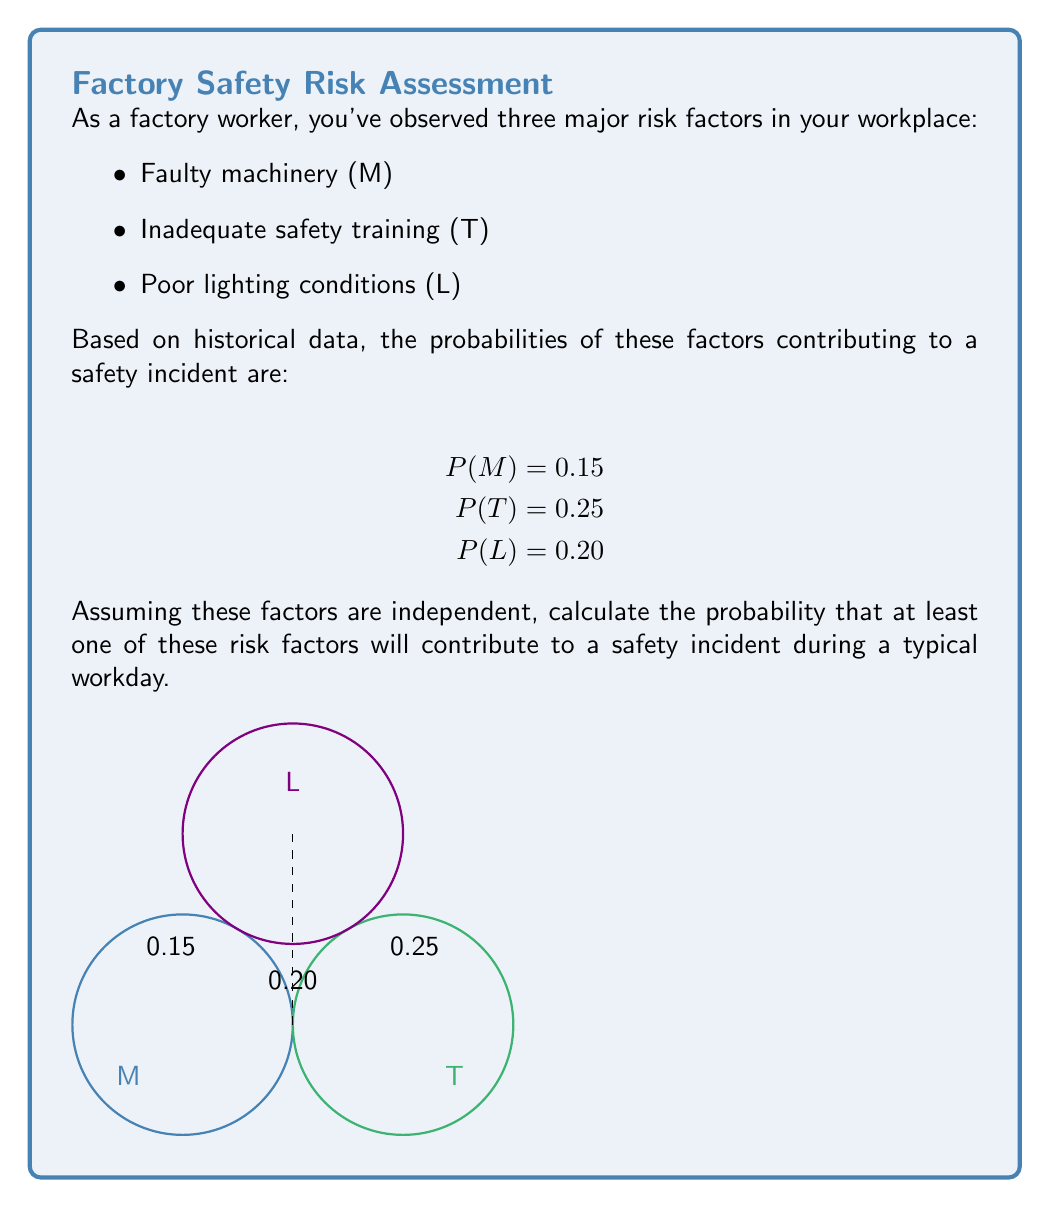Could you help me with this problem? Let's approach this step-by-step using the complement method:

1) First, we need to find the probability that none of the risk factors contribute to a safety incident. This is equivalent to the probability that all factors do not occur.

2) For each factor, the probability of it not occurring is:
   P(not M) = 1 - P(M) = 1 - 0.15 = 0.85
   P(not T) = 1 - P(T) = 1 - 0.25 = 0.75
   P(not L) = 1 - P(L) = 1 - 0.20 = 0.80

3) Since the factors are independent, we can multiply these probabilities:
   P(none occur) = P(not M) × P(not T) × P(not L)
                 = 0.85 × 0.75 × 0.80
                 = 0.51

4) Now, the probability that at least one factor contributes to a safety incident is the complement of the probability that none occur:

   P(at least one occurs) = 1 - P(none occur)
                          = 1 - 0.51
                          = 0.49

5) We can also express this using the equation:

   $$P(\text{at least one}) = 1 - (1-P(M))(1-P(T))(1-P(L))$$

Therefore, the probability that at least one of these risk factors will contribute to a safety incident during a typical workday is 0.49 or 49%.
Answer: 0.49 